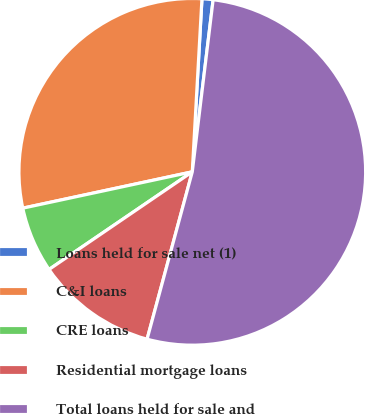Convert chart to OTSL. <chart><loc_0><loc_0><loc_500><loc_500><pie_chart><fcel>Loans held for sale net (1)<fcel>C&I loans<fcel>CRE loans<fcel>Residential mortgage loans<fcel>Total loans held for sale and<nl><fcel>1.03%<fcel>29.25%<fcel>6.16%<fcel>11.28%<fcel>52.28%<nl></chart> 